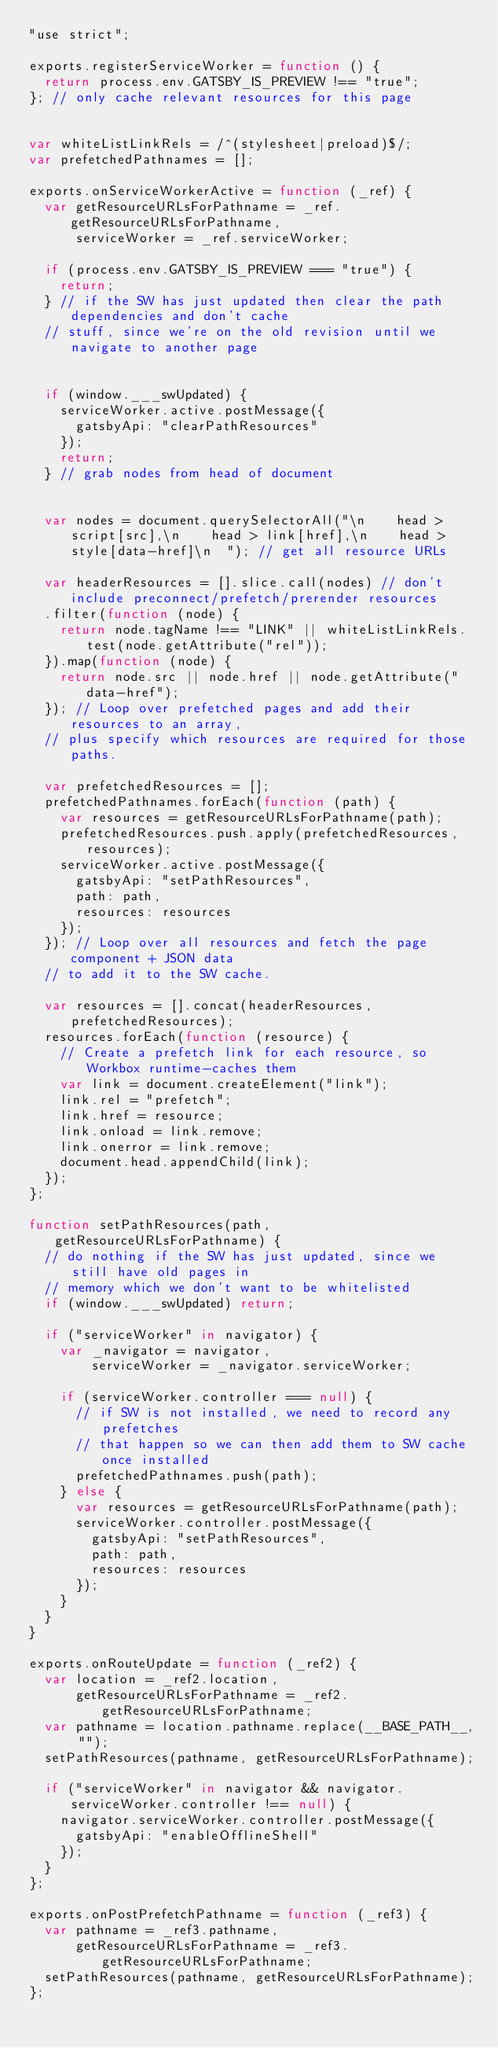<code> <loc_0><loc_0><loc_500><loc_500><_JavaScript_>"use strict";

exports.registerServiceWorker = function () {
  return process.env.GATSBY_IS_PREVIEW !== "true";
}; // only cache relevant resources for this page


var whiteListLinkRels = /^(stylesheet|preload)$/;
var prefetchedPathnames = [];

exports.onServiceWorkerActive = function (_ref) {
  var getResourceURLsForPathname = _ref.getResourceURLsForPathname,
      serviceWorker = _ref.serviceWorker;

  if (process.env.GATSBY_IS_PREVIEW === "true") {
    return;
  } // if the SW has just updated then clear the path dependencies and don't cache
  // stuff, since we're on the old revision until we navigate to another page


  if (window.___swUpdated) {
    serviceWorker.active.postMessage({
      gatsbyApi: "clearPathResources"
    });
    return;
  } // grab nodes from head of document


  var nodes = document.querySelectorAll("\n    head > script[src],\n    head > link[href],\n    head > style[data-href]\n  "); // get all resource URLs

  var headerResources = [].slice.call(nodes) // don't include preconnect/prefetch/prerender resources
  .filter(function (node) {
    return node.tagName !== "LINK" || whiteListLinkRels.test(node.getAttribute("rel"));
  }).map(function (node) {
    return node.src || node.href || node.getAttribute("data-href");
  }); // Loop over prefetched pages and add their resources to an array,
  // plus specify which resources are required for those paths.

  var prefetchedResources = [];
  prefetchedPathnames.forEach(function (path) {
    var resources = getResourceURLsForPathname(path);
    prefetchedResources.push.apply(prefetchedResources, resources);
    serviceWorker.active.postMessage({
      gatsbyApi: "setPathResources",
      path: path,
      resources: resources
    });
  }); // Loop over all resources and fetch the page component + JSON data
  // to add it to the SW cache.

  var resources = [].concat(headerResources, prefetchedResources);
  resources.forEach(function (resource) {
    // Create a prefetch link for each resource, so Workbox runtime-caches them
    var link = document.createElement("link");
    link.rel = "prefetch";
    link.href = resource;
    link.onload = link.remove;
    link.onerror = link.remove;
    document.head.appendChild(link);
  });
};

function setPathResources(path, getResourceURLsForPathname) {
  // do nothing if the SW has just updated, since we still have old pages in
  // memory which we don't want to be whitelisted
  if (window.___swUpdated) return;

  if ("serviceWorker" in navigator) {
    var _navigator = navigator,
        serviceWorker = _navigator.serviceWorker;

    if (serviceWorker.controller === null) {
      // if SW is not installed, we need to record any prefetches
      // that happen so we can then add them to SW cache once installed
      prefetchedPathnames.push(path);
    } else {
      var resources = getResourceURLsForPathname(path);
      serviceWorker.controller.postMessage({
        gatsbyApi: "setPathResources",
        path: path,
        resources: resources
      });
    }
  }
}

exports.onRouteUpdate = function (_ref2) {
  var location = _ref2.location,
      getResourceURLsForPathname = _ref2.getResourceURLsForPathname;
  var pathname = location.pathname.replace(__BASE_PATH__, "");
  setPathResources(pathname, getResourceURLsForPathname);

  if ("serviceWorker" in navigator && navigator.serviceWorker.controller !== null) {
    navigator.serviceWorker.controller.postMessage({
      gatsbyApi: "enableOfflineShell"
    });
  }
};

exports.onPostPrefetchPathname = function (_ref3) {
  var pathname = _ref3.pathname,
      getResourceURLsForPathname = _ref3.getResourceURLsForPathname;
  setPathResources(pathname, getResourceURLsForPathname);
};</code> 